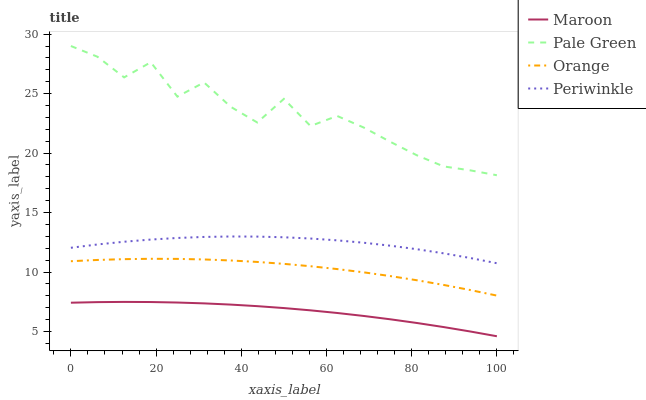Does Maroon have the minimum area under the curve?
Answer yes or no. Yes. Does Pale Green have the maximum area under the curve?
Answer yes or no. Yes. Does Periwinkle have the minimum area under the curve?
Answer yes or no. No. Does Periwinkle have the maximum area under the curve?
Answer yes or no. No. Is Maroon the smoothest?
Answer yes or no. Yes. Is Pale Green the roughest?
Answer yes or no. Yes. Is Periwinkle the smoothest?
Answer yes or no. No. Is Periwinkle the roughest?
Answer yes or no. No. Does Maroon have the lowest value?
Answer yes or no. Yes. Does Periwinkle have the lowest value?
Answer yes or no. No. Does Pale Green have the highest value?
Answer yes or no. Yes. Does Periwinkle have the highest value?
Answer yes or no. No. Is Periwinkle less than Pale Green?
Answer yes or no. Yes. Is Periwinkle greater than Orange?
Answer yes or no. Yes. Does Periwinkle intersect Pale Green?
Answer yes or no. No. 